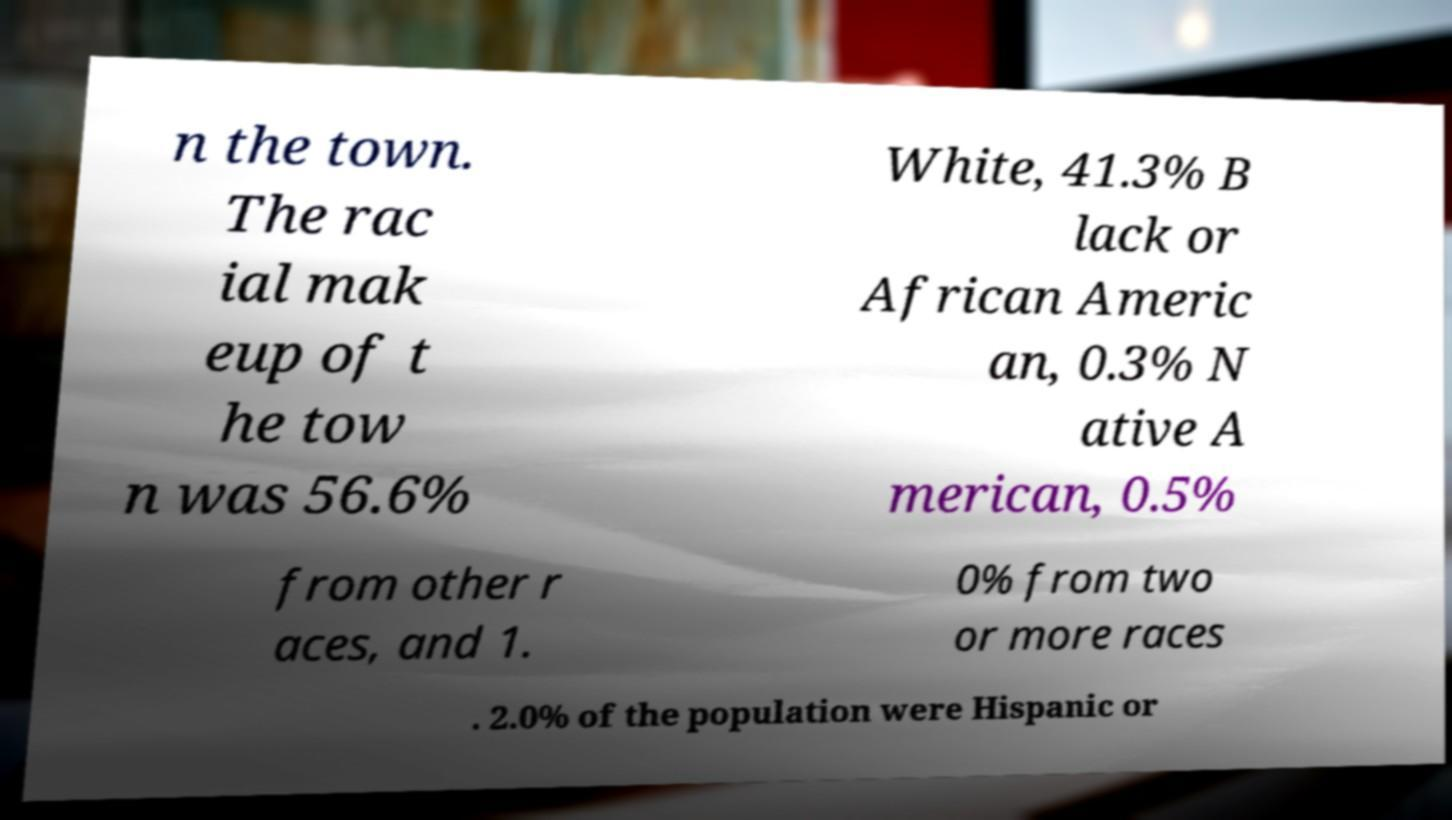Could you assist in decoding the text presented in this image and type it out clearly? n the town. The rac ial mak eup of t he tow n was 56.6% White, 41.3% B lack or African Americ an, 0.3% N ative A merican, 0.5% from other r aces, and 1. 0% from two or more races . 2.0% of the population were Hispanic or 